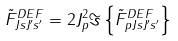<formula> <loc_0><loc_0><loc_500><loc_500>\tilde { F } _ { J s J ^ { \prime } s ^ { \prime } } ^ { D E F } = 2 J _ { p } ^ { 2 } \Im \left \{ \tilde { F } _ { p J s J ^ { \prime } s ^ { \prime } } ^ { D E F } \right \}</formula> 